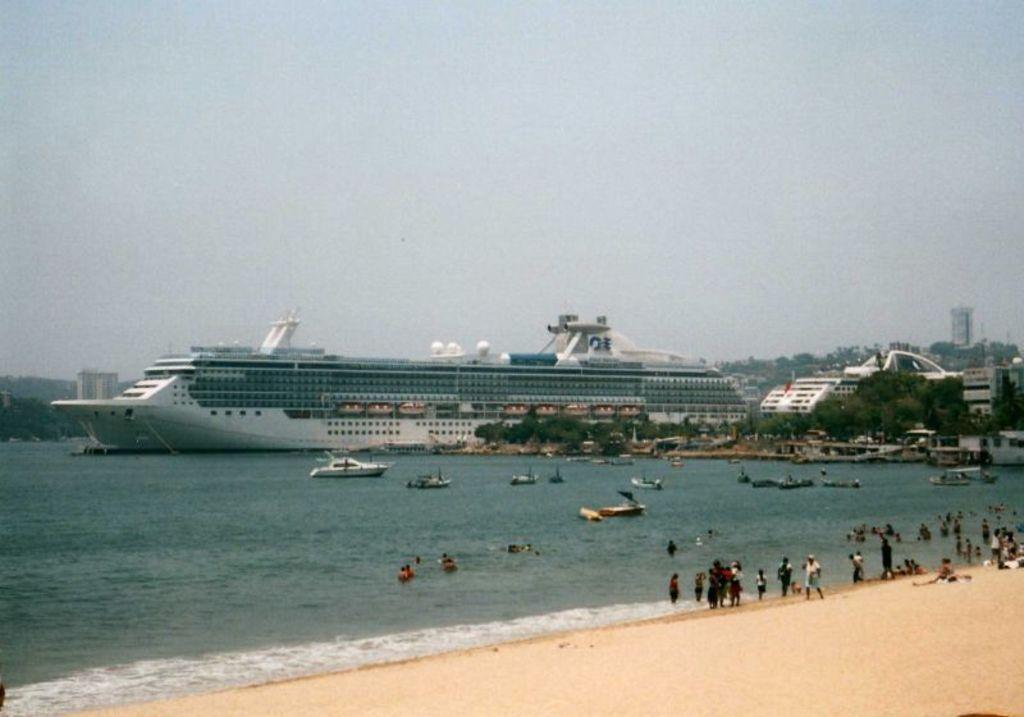In one or two sentences, can you explain what this image depicts? In this image we can see boats and cruise on the surface of water. At the bottom of the image people are standing on the beach. Background of the image, buildings are there. At the top of the image sky is there. 